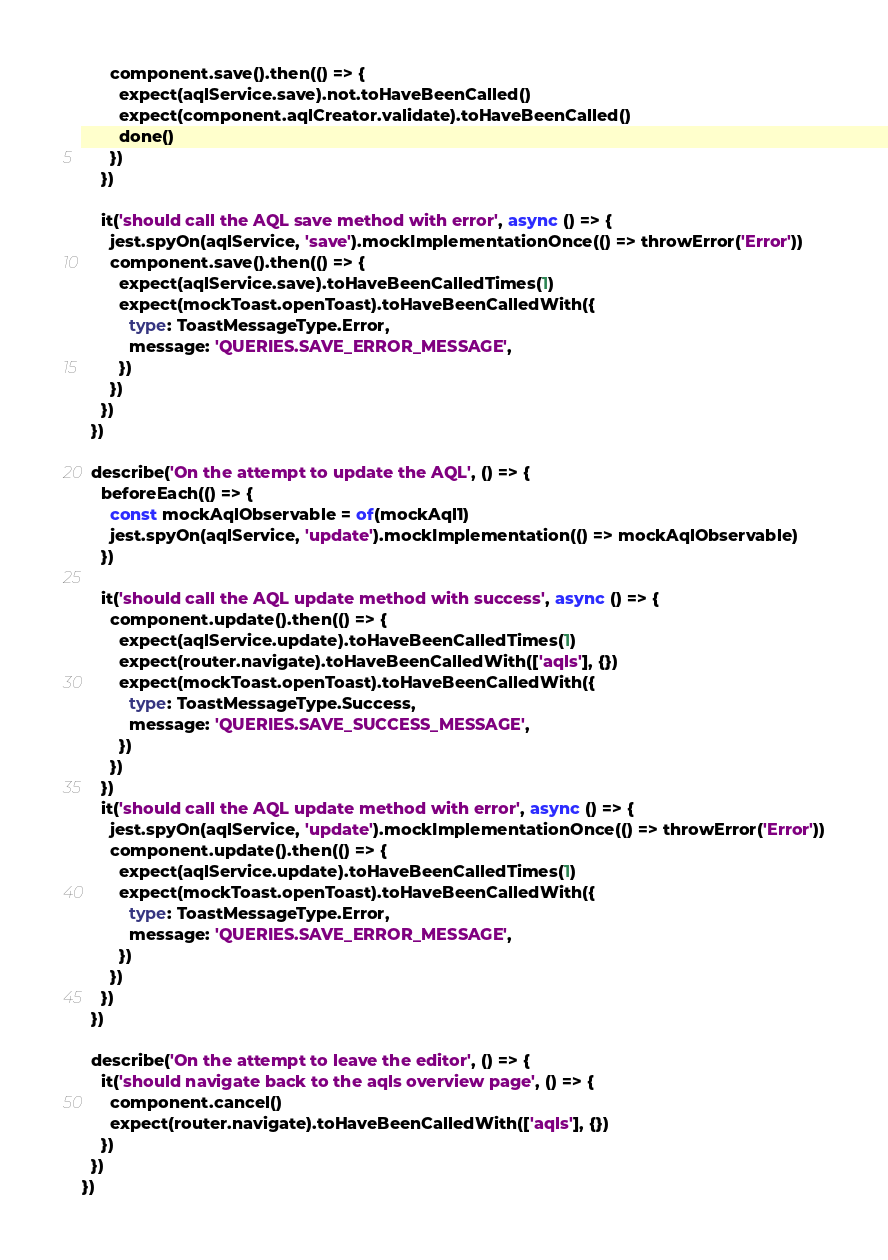Convert code to text. <code><loc_0><loc_0><loc_500><loc_500><_TypeScript_>      component.save().then(() => {
        expect(aqlService.save).not.toHaveBeenCalled()
        expect(component.aqlCreator.validate).toHaveBeenCalled()
        done()
      })
    })

    it('should call the AQL save method with error', async () => {
      jest.spyOn(aqlService, 'save').mockImplementationOnce(() => throwError('Error'))
      component.save().then(() => {
        expect(aqlService.save).toHaveBeenCalledTimes(1)
        expect(mockToast.openToast).toHaveBeenCalledWith({
          type: ToastMessageType.Error,
          message: 'QUERIES.SAVE_ERROR_MESSAGE',
        })
      })
    })
  })

  describe('On the attempt to update the AQL', () => {
    beforeEach(() => {
      const mockAqlObservable = of(mockAql1)
      jest.spyOn(aqlService, 'update').mockImplementation(() => mockAqlObservable)
    })

    it('should call the AQL update method with success', async () => {
      component.update().then(() => {
        expect(aqlService.update).toHaveBeenCalledTimes(1)
        expect(router.navigate).toHaveBeenCalledWith(['aqls'], {})
        expect(mockToast.openToast).toHaveBeenCalledWith({
          type: ToastMessageType.Success,
          message: 'QUERIES.SAVE_SUCCESS_MESSAGE',
        })
      })
    })
    it('should call the AQL update method with error', async () => {
      jest.spyOn(aqlService, 'update').mockImplementationOnce(() => throwError('Error'))
      component.update().then(() => {
        expect(aqlService.update).toHaveBeenCalledTimes(1)
        expect(mockToast.openToast).toHaveBeenCalledWith({
          type: ToastMessageType.Error,
          message: 'QUERIES.SAVE_ERROR_MESSAGE',
        })
      })
    })
  })

  describe('On the attempt to leave the editor', () => {
    it('should navigate back to the aqls overview page', () => {
      component.cancel()
      expect(router.navigate).toHaveBeenCalledWith(['aqls'], {})
    })
  })
})
</code> 